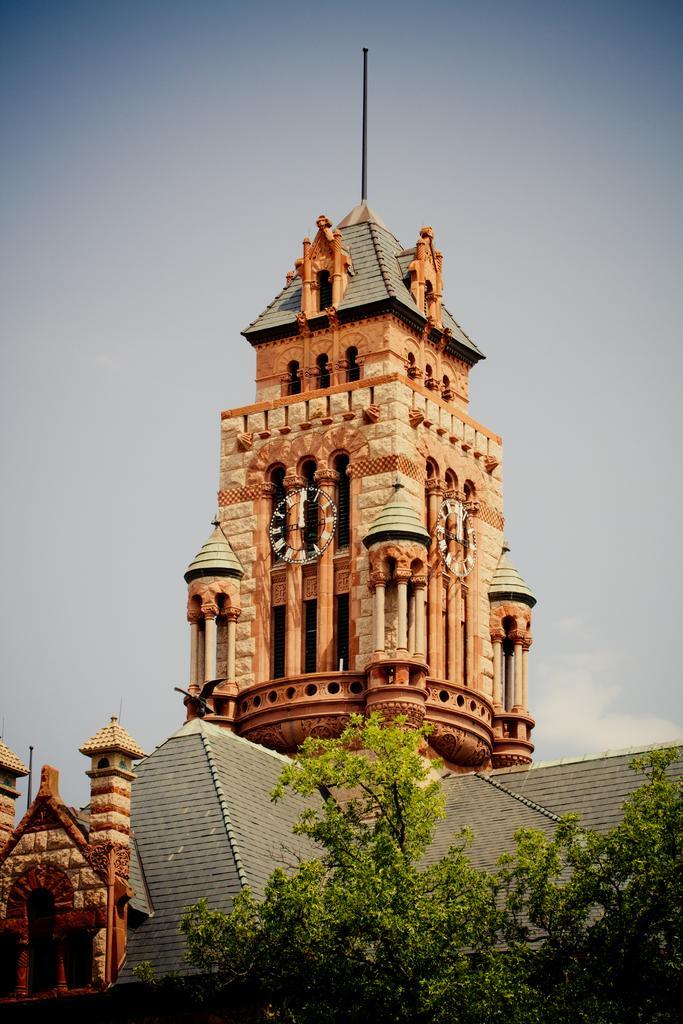Could you give a brief overview of what you see in this image? In this image, we can see a clock tower. There are trees and roofs at the bottom of the image. At the top of the image, we can see the sky. 